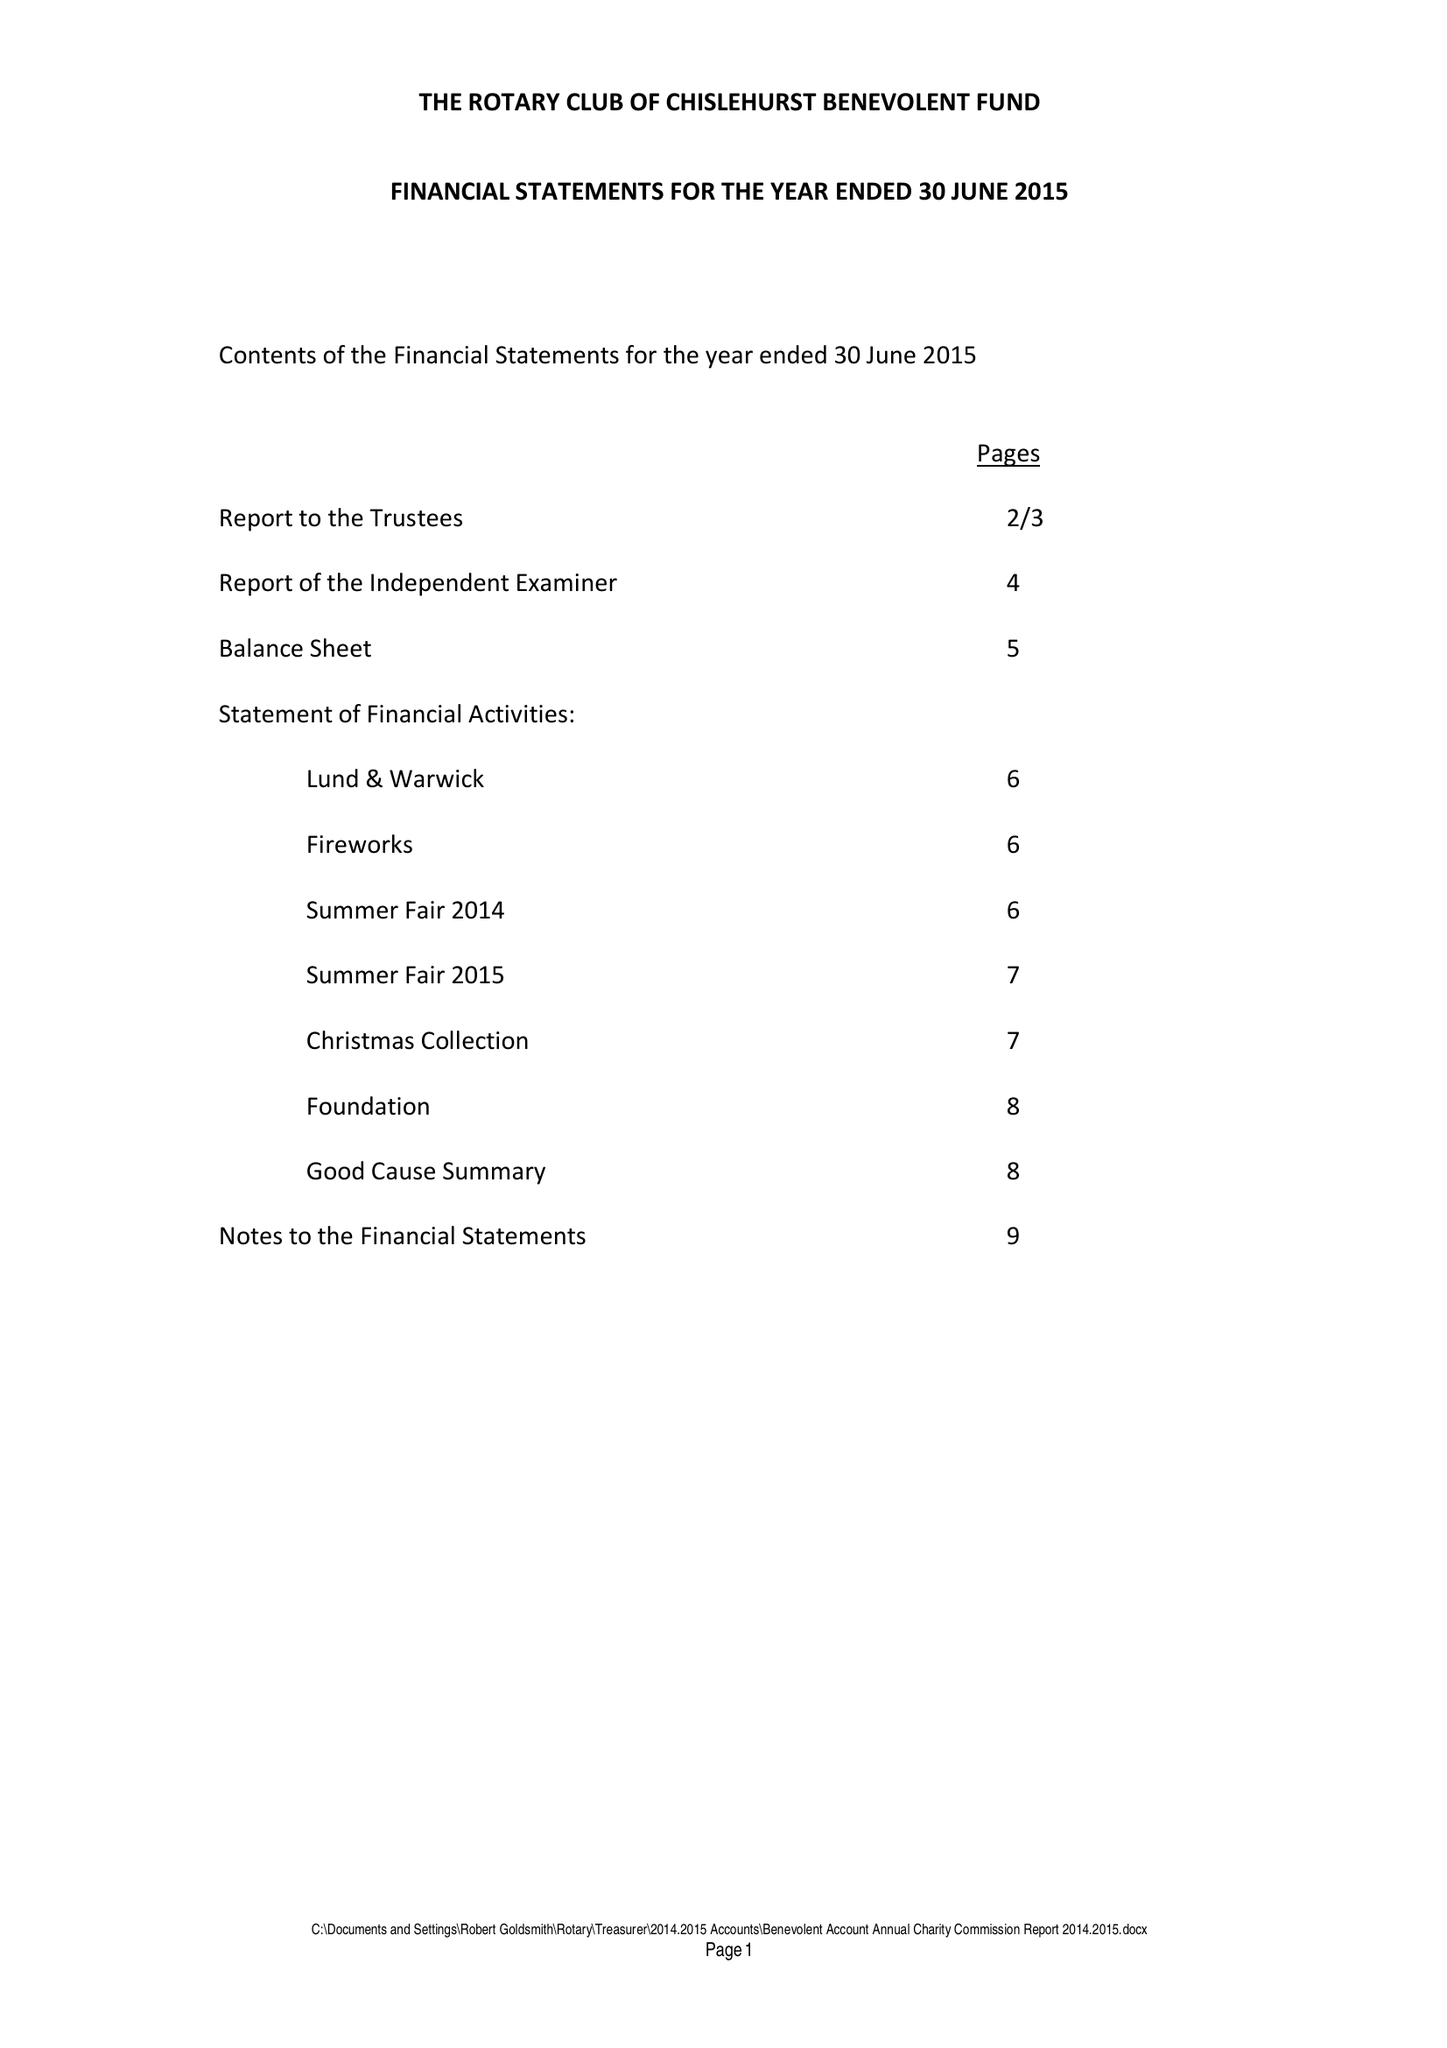What is the value for the report_date?
Answer the question using a single word or phrase. 2015-06-30 